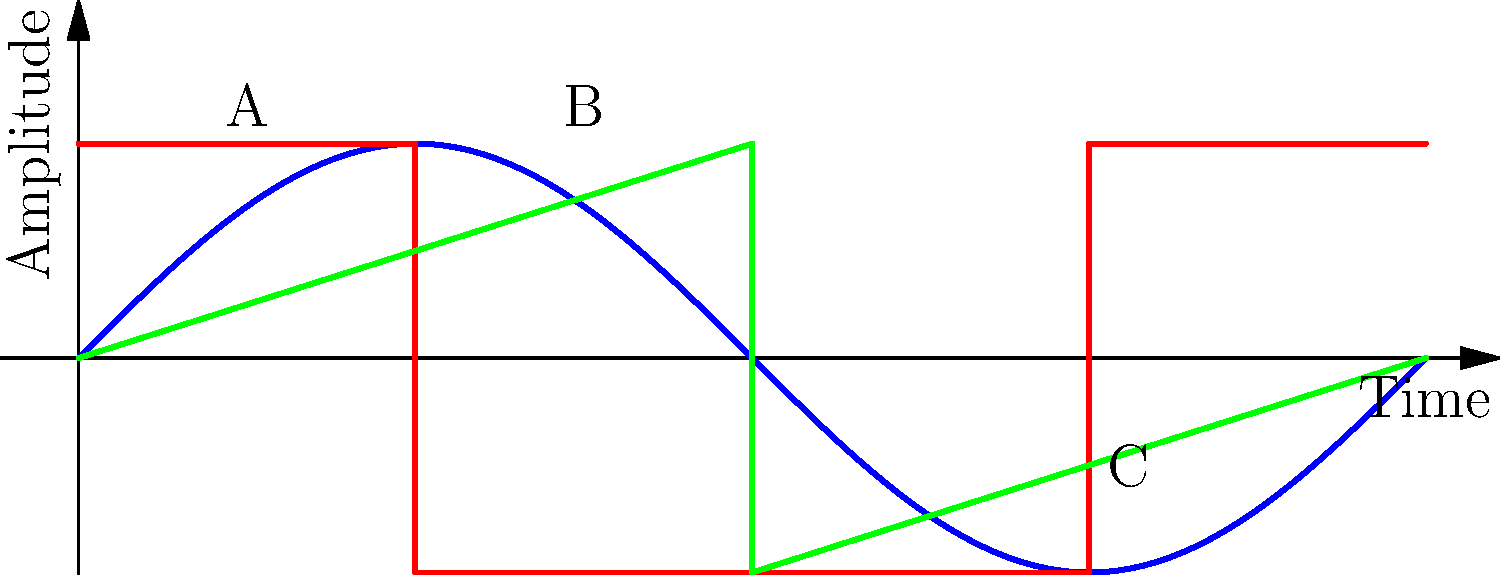As a music producer collaborating with aspiring artists, you often work with various audio waveforms. In the graph above, three common waveforms are shown: sine, square, and sawtooth. Which waveform is represented by the curve labeled 'B', and what characteristic makes it unique in audio production? To answer this question, let's analyze the three waveforms shown in the graph:

1. Curve A (blue): This is a sine wave, characterized by its smooth, continuous oscillation.

2. Curve B (red): This is a square wave, distinguished by its abrupt transitions between two fixed voltage levels, creating a rectangular shape.

3. Curve C (green): This is a sawtooth wave, recognized by its linear rise followed by a sharp drop, resembling the teeth of a saw.

The curve labeled 'B' is the square wave. Its unique characteristic in audio production is:

1. Harmonic content: Square waves contain only odd harmonics, which gives them a distinct "hollow" or "woodwind-like" timbre.

2. Instant transitions: The abrupt changes between high and low states create a "buzzy" quality in the sound.

3. Symmetry: The equal time spent at both high and low states results in a balanced tone.

4. Rich in overtones: This makes square waves useful for creating full, complex sounds in synthesis.

5. Easily manipulated: In audio production, square waves can be filtered or processed to create a wide range of tones, from bass-heavy sounds to thin, reedy timbres.

This waveform is particularly useful in synthesizer programming and sound design, allowing producers to create distinctive electronic and industrial sounds.
Answer: Square wave; rich in odd harmonics, creating a "hollow" timbre with instant transitions. 